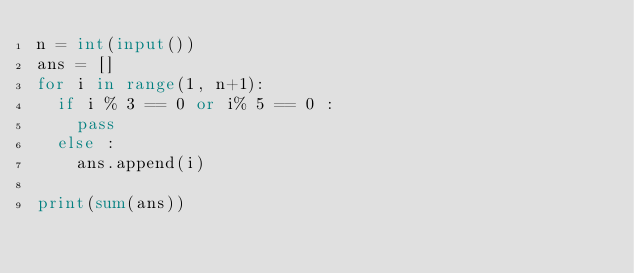<code> <loc_0><loc_0><loc_500><loc_500><_Python_>n = int(input())
ans = []
for i in range(1, n+1):
  if i % 3 == 0 or i% 5 == 0 :
    pass
  else :
    ans.append(i)

print(sum(ans))</code> 